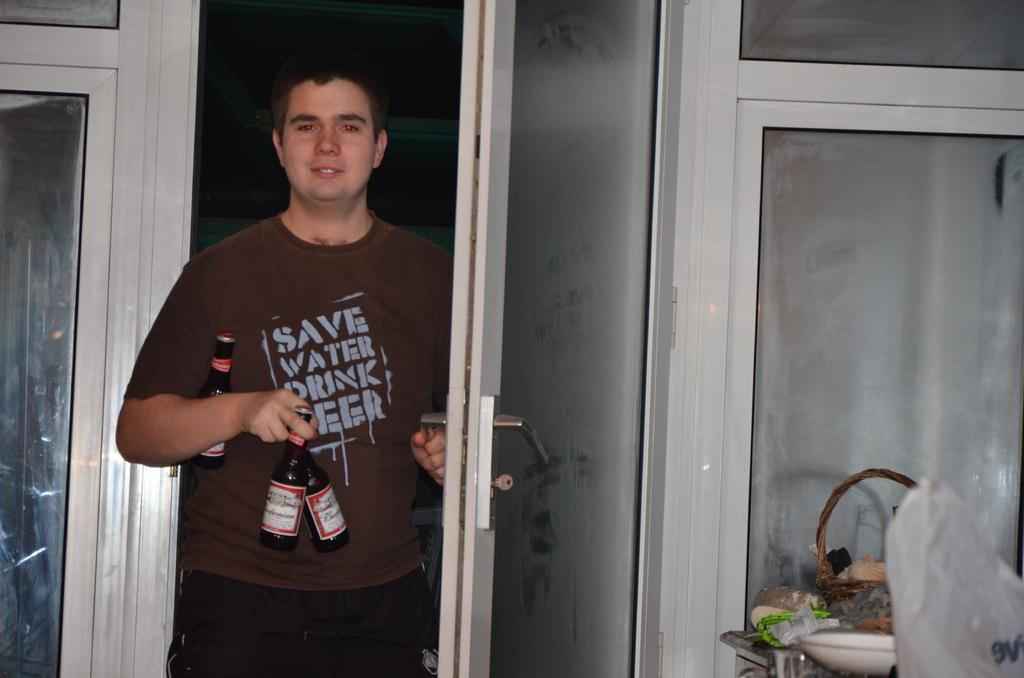Who is present in the image? There is a man in the image. What is the man holding in the image? The man is holding 3 beer bottles. What action is the man performing in the image? The man is opening a door. What can be seen in the right corner of the image? There is a bag in the right corner of the image. What objects are visible on the countertop in the image? There are objects on the countertop. Where is the bomb located in the image? There is no bomb present in the image. Can you describe the kitty playing with the man in the image? There is no kitty present in the image. 